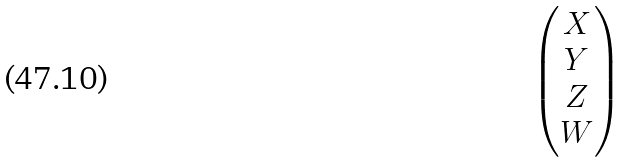<formula> <loc_0><loc_0><loc_500><loc_500>\begin{pmatrix} X \\ Y \\ Z \\ W \end{pmatrix}</formula> 